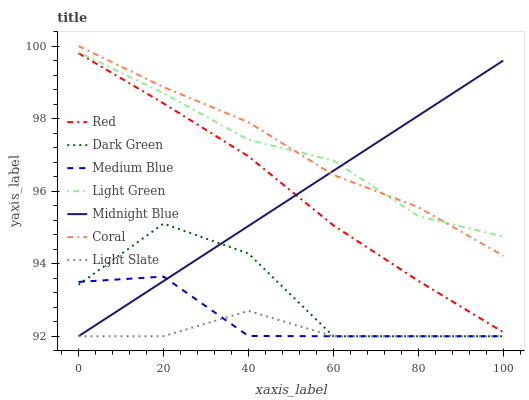Does Light Slate have the minimum area under the curve?
Answer yes or no. Yes. Does Coral have the maximum area under the curve?
Answer yes or no. Yes. Does Coral have the minimum area under the curve?
Answer yes or no. No. Does Light Slate have the maximum area under the curve?
Answer yes or no. No. Is Midnight Blue the smoothest?
Answer yes or no. Yes. Is Dark Green the roughest?
Answer yes or no. Yes. Is Light Slate the smoothest?
Answer yes or no. No. Is Light Slate the roughest?
Answer yes or no. No. Does Coral have the lowest value?
Answer yes or no. No. Does Coral have the highest value?
Answer yes or no. Yes. Does Light Slate have the highest value?
Answer yes or no. No. Is Red less than Light Green?
Answer yes or no. Yes. Is Coral greater than Dark Green?
Answer yes or no. Yes. Does Red intersect Midnight Blue?
Answer yes or no. Yes. Is Red less than Midnight Blue?
Answer yes or no. No. Is Red greater than Midnight Blue?
Answer yes or no. No. Does Red intersect Light Green?
Answer yes or no. No. 